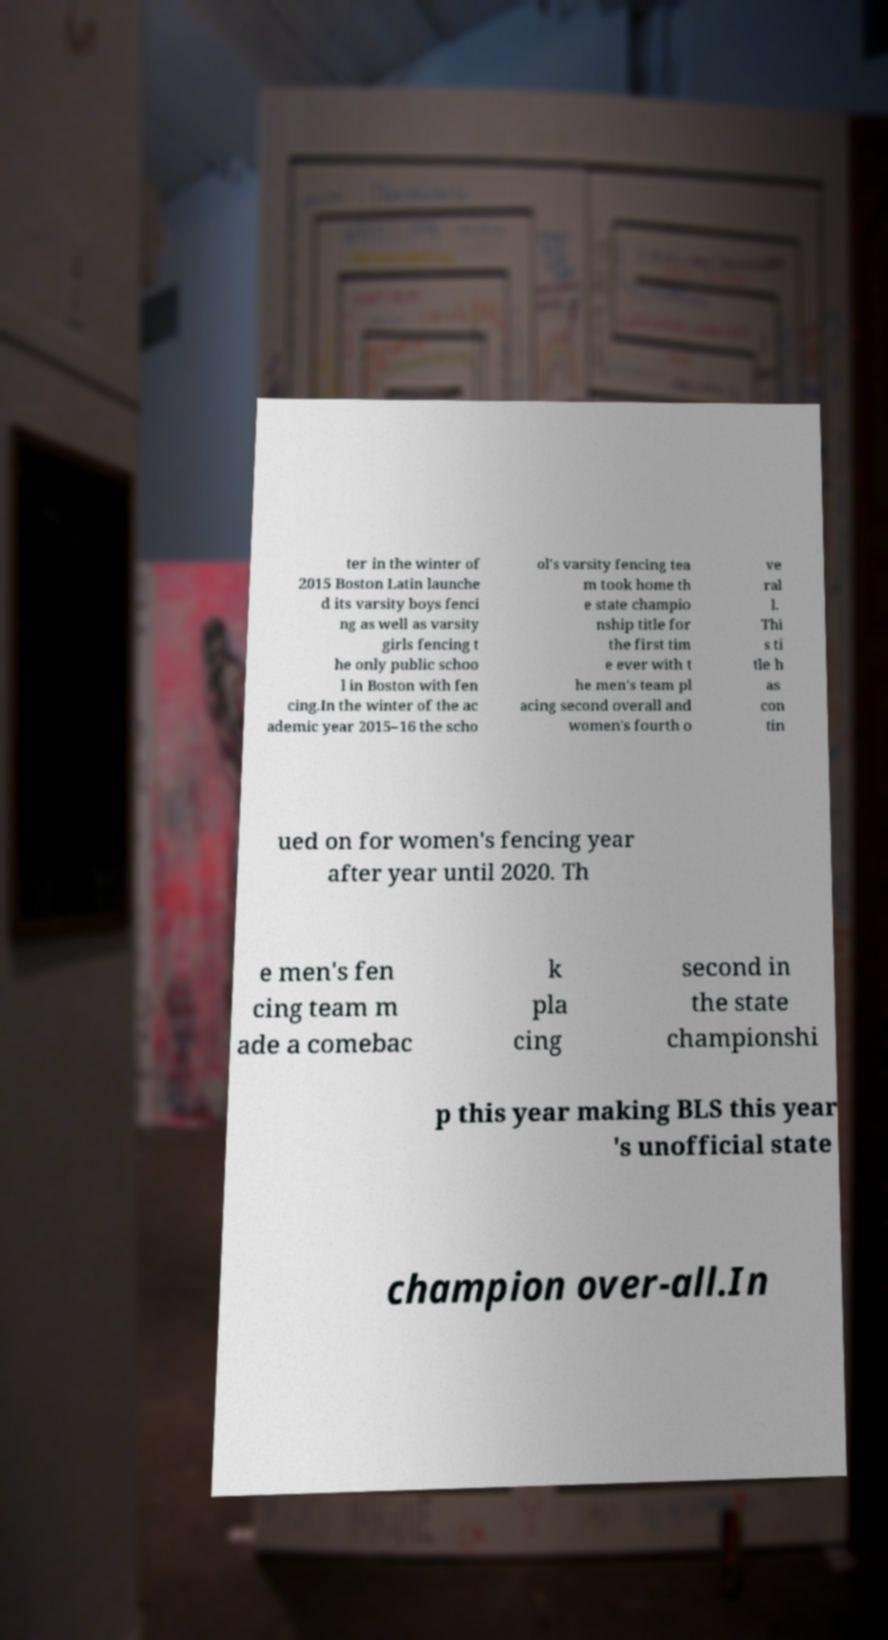Please identify and transcribe the text found in this image. ter in the winter of 2015 Boston Latin launche d its varsity boys fenci ng as well as varsity girls fencing t he only public schoo l in Boston with fen cing.In the winter of the ac ademic year 2015–16 the scho ol's varsity fencing tea m took home th e state champio nship title for the first tim e ever with t he men's team pl acing second overall and women's fourth o ve ral l. Thi s ti tle h as con tin ued on for women's fencing year after year until 2020. Th e men's fen cing team m ade a comebac k pla cing second in the state championshi p this year making BLS this year 's unofficial state champion over-all.In 